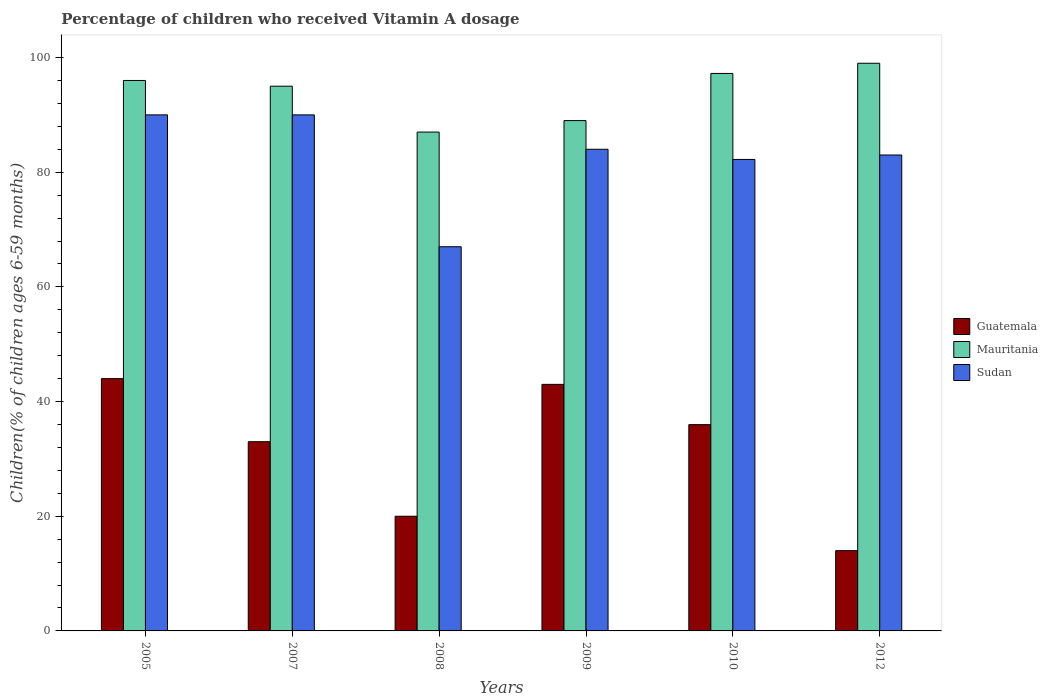How many different coloured bars are there?
Your answer should be compact. 3. Are the number of bars per tick equal to the number of legend labels?
Your answer should be compact. Yes. How many bars are there on the 4th tick from the left?
Your answer should be very brief. 3. What is the label of the 2nd group of bars from the left?
Ensure brevity in your answer.  2007. In how many cases, is the number of bars for a given year not equal to the number of legend labels?
Give a very brief answer. 0. What is the percentage of children who received Vitamin A dosage in Mauritania in 2009?
Your answer should be very brief. 89. Across all years, what is the maximum percentage of children who received Vitamin A dosage in Mauritania?
Keep it short and to the point. 99. In which year was the percentage of children who received Vitamin A dosage in Mauritania maximum?
Your answer should be very brief. 2012. In which year was the percentage of children who received Vitamin A dosage in Sudan minimum?
Ensure brevity in your answer.  2008. What is the total percentage of children who received Vitamin A dosage in Guatemala in the graph?
Your answer should be very brief. 189.98. What is the difference between the percentage of children who received Vitamin A dosage in Mauritania in 2007 and that in 2008?
Your answer should be compact. 8. What is the difference between the percentage of children who received Vitamin A dosage in Sudan in 2007 and the percentage of children who received Vitamin A dosage in Mauritania in 2005?
Your answer should be compact. -6. What is the average percentage of children who received Vitamin A dosage in Mauritania per year?
Your response must be concise. 93.87. In how many years, is the percentage of children who received Vitamin A dosage in Sudan greater than 56 %?
Give a very brief answer. 6. What is the ratio of the percentage of children who received Vitamin A dosage in Sudan in 2010 to that in 2012?
Your response must be concise. 0.99. Is the percentage of children who received Vitamin A dosage in Mauritania in 2007 less than that in 2009?
Your answer should be very brief. No. Is the difference between the percentage of children who received Vitamin A dosage in Sudan in 2005 and 2008 greater than the difference between the percentage of children who received Vitamin A dosage in Guatemala in 2005 and 2008?
Make the answer very short. No. In how many years, is the percentage of children who received Vitamin A dosage in Mauritania greater than the average percentage of children who received Vitamin A dosage in Mauritania taken over all years?
Ensure brevity in your answer.  4. Is the sum of the percentage of children who received Vitamin A dosage in Mauritania in 2008 and 2012 greater than the maximum percentage of children who received Vitamin A dosage in Guatemala across all years?
Make the answer very short. Yes. What does the 3rd bar from the left in 2012 represents?
Offer a very short reply. Sudan. What does the 3rd bar from the right in 2009 represents?
Make the answer very short. Guatemala. Is it the case that in every year, the sum of the percentage of children who received Vitamin A dosage in Mauritania and percentage of children who received Vitamin A dosage in Sudan is greater than the percentage of children who received Vitamin A dosage in Guatemala?
Offer a terse response. Yes. How many years are there in the graph?
Keep it short and to the point. 6. What is the difference between two consecutive major ticks on the Y-axis?
Provide a short and direct response. 20. Where does the legend appear in the graph?
Make the answer very short. Center right. How many legend labels are there?
Give a very brief answer. 3. What is the title of the graph?
Your response must be concise. Percentage of children who received Vitamin A dosage. What is the label or title of the Y-axis?
Give a very brief answer. Children(% of children ages 6-59 months). What is the Children(% of children ages 6-59 months) of Mauritania in 2005?
Offer a very short reply. 96. What is the Children(% of children ages 6-59 months) of Mauritania in 2007?
Provide a short and direct response. 95. What is the Children(% of children ages 6-59 months) of Sudan in 2007?
Offer a terse response. 90. What is the Children(% of children ages 6-59 months) in Mauritania in 2009?
Your response must be concise. 89. What is the Children(% of children ages 6-59 months) of Guatemala in 2010?
Make the answer very short. 35.98. What is the Children(% of children ages 6-59 months) of Mauritania in 2010?
Give a very brief answer. 97.22. What is the Children(% of children ages 6-59 months) of Sudan in 2010?
Your answer should be compact. 82.23. What is the Children(% of children ages 6-59 months) of Guatemala in 2012?
Your answer should be very brief. 14. What is the Children(% of children ages 6-59 months) in Sudan in 2012?
Provide a succinct answer. 83. Across all years, what is the maximum Children(% of children ages 6-59 months) in Guatemala?
Provide a short and direct response. 44. Across all years, what is the minimum Children(% of children ages 6-59 months) in Guatemala?
Your response must be concise. 14. What is the total Children(% of children ages 6-59 months) in Guatemala in the graph?
Provide a succinct answer. 189.98. What is the total Children(% of children ages 6-59 months) in Mauritania in the graph?
Your answer should be compact. 563.22. What is the total Children(% of children ages 6-59 months) of Sudan in the graph?
Give a very brief answer. 496.23. What is the difference between the Children(% of children ages 6-59 months) in Guatemala in 2005 and that in 2007?
Offer a very short reply. 11. What is the difference between the Children(% of children ages 6-59 months) in Sudan in 2005 and that in 2007?
Keep it short and to the point. 0. What is the difference between the Children(% of children ages 6-59 months) of Sudan in 2005 and that in 2008?
Your answer should be compact. 23. What is the difference between the Children(% of children ages 6-59 months) of Guatemala in 2005 and that in 2009?
Make the answer very short. 1. What is the difference between the Children(% of children ages 6-59 months) in Mauritania in 2005 and that in 2009?
Make the answer very short. 7. What is the difference between the Children(% of children ages 6-59 months) in Guatemala in 2005 and that in 2010?
Provide a short and direct response. 8.02. What is the difference between the Children(% of children ages 6-59 months) in Mauritania in 2005 and that in 2010?
Make the answer very short. -1.22. What is the difference between the Children(% of children ages 6-59 months) of Sudan in 2005 and that in 2010?
Make the answer very short. 7.77. What is the difference between the Children(% of children ages 6-59 months) in Guatemala in 2005 and that in 2012?
Your response must be concise. 30. What is the difference between the Children(% of children ages 6-59 months) in Mauritania in 2007 and that in 2008?
Offer a terse response. 8. What is the difference between the Children(% of children ages 6-59 months) of Guatemala in 2007 and that in 2009?
Ensure brevity in your answer.  -10. What is the difference between the Children(% of children ages 6-59 months) of Guatemala in 2007 and that in 2010?
Your answer should be very brief. -2.98. What is the difference between the Children(% of children ages 6-59 months) in Mauritania in 2007 and that in 2010?
Offer a very short reply. -2.22. What is the difference between the Children(% of children ages 6-59 months) in Sudan in 2007 and that in 2010?
Provide a short and direct response. 7.77. What is the difference between the Children(% of children ages 6-59 months) of Mauritania in 2007 and that in 2012?
Ensure brevity in your answer.  -4. What is the difference between the Children(% of children ages 6-59 months) of Guatemala in 2008 and that in 2009?
Make the answer very short. -23. What is the difference between the Children(% of children ages 6-59 months) in Mauritania in 2008 and that in 2009?
Keep it short and to the point. -2. What is the difference between the Children(% of children ages 6-59 months) in Sudan in 2008 and that in 2009?
Keep it short and to the point. -17. What is the difference between the Children(% of children ages 6-59 months) of Guatemala in 2008 and that in 2010?
Offer a terse response. -15.98. What is the difference between the Children(% of children ages 6-59 months) in Mauritania in 2008 and that in 2010?
Provide a short and direct response. -10.22. What is the difference between the Children(% of children ages 6-59 months) in Sudan in 2008 and that in 2010?
Ensure brevity in your answer.  -15.23. What is the difference between the Children(% of children ages 6-59 months) of Guatemala in 2008 and that in 2012?
Provide a succinct answer. 6. What is the difference between the Children(% of children ages 6-59 months) in Mauritania in 2008 and that in 2012?
Provide a succinct answer. -12. What is the difference between the Children(% of children ages 6-59 months) of Sudan in 2008 and that in 2012?
Give a very brief answer. -16. What is the difference between the Children(% of children ages 6-59 months) in Guatemala in 2009 and that in 2010?
Give a very brief answer. 7.02. What is the difference between the Children(% of children ages 6-59 months) of Mauritania in 2009 and that in 2010?
Provide a short and direct response. -8.22. What is the difference between the Children(% of children ages 6-59 months) in Sudan in 2009 and that in 2010?
Provide a short and direct response. 1.77. What is the difference between the Children(% of children ages 6-59 months) of Sudan in 2009 and that in 2012?
Give a very brief answer. 1. What is the difference between the Children(% of children ages 6-59 months) of Guatemala in 2010 and that in 2012?
Your answer should be very brief. 21.98. What is the difference between the Children(% of children ages 6-59 months) of Mauritania in 2010 and that in 2012?
Offer a very short reply. -1.78. What is the difference between the Children(% of children ages 6-59 months) of Sudan in 2010 and that in 2012?
Offer a very short reply. -0.77. What is the difference between the Children(% of children ages 6-59 months) in Guatemala in 2005 and the Children(% of children ages 6-59 months) in Mauritania in 2007?
Provide a succinct answer. -51. What is the difference between the Children(% of children ages 6-59 months) of Guatemala in 2005 and the Children(% of children ages 6-59 months) of Sudan in 2007?
Give a very brief answer. -46. What is the difference between the Children(% of children ages 6-59 months) of Mauritania in 2005 and the Children(% of children ages 6-59 months) of Sudan in 2007?
Your response must be concise. 6. What is the difference between the Children(% of children ages 6-59 months) of Guatemala in 2005 and the Children(% of children ages 6-59 months) of Mauritania in 2008?
Make the answer very short. -43. What is the difference between the Children(% of children ages 6-59 months) of Mauritania in 2005 and the Children(% of children ages 6-59 months) of Sudan in 2008?
Provide a short and direct response. 29. What is the difference between the Children(% of children ages 6-59 months) in Guatemala in 2005 and the Children(% of children ages 6-59 months) in Mauritania in 2009?
Keep it short and to the point. -45. What is the difference between the Children(% of children ages 6-59 months) of Guatemala in 2005 and the Children(% of children ages 6-59 months) of Sudan in 2009?
Your answer should be compact. -40. What is the difference between the Children(% of children ages 6-59 months) in Mauritania in 2005 and the Children(% of children ages 6-59 months) in Sudan in 2009?
Make the answer very short. 12. What is the difference between the Children(% of children ages 6-59 months) in Guatemala in 2005 and the Children(% of children ages 6-59 months) in Mauritania in 2010?
Ensure brevity in your answer.  -53.22. What is the difference between the Children(% of children ages 6-59 months) in Guatemala in 2005 and the Children(% of children ages 6-59 months) in Sudan in 2010?
Give a very brief answer. -38.23. What is the difference between the Children(% of children ages 6-59 months) of Mauritania in 2005 and the Children(% of children ages 6-59 months) of Sudan in 2010?
Keep it short and to the point. 13.77. What is the difference between the Children(% of children ages 6-59 months) in Guatemala in 2005 and the Children(% of children ages 6-59 months) in Mauritania in 2012?
Keep it short and to the point. -55. What is the difference between the Children(% of children ages 6-59 months) of Guatemala in 2005 and the Children(% of children ages 6-59 months) of Sudan in 2012?
Provide a succinct answer. -39. What is the difference between the Children(% of children ages 6-59 months) in Mauritania in 2005 and the Children(% of children ages 6-59 months) in Sudan in 2012?
Offer a very short reply. 13. What is the difference between the Children(% of children ages 6-59 months) in Guatemala in 2007 and the Children(% of children ages 6-59 months) in Mauritania in 2008?
Your response must be concise. -54. What is the difference between the Children(% of children ages 6-59 months) of Guatemala in 2007 and the Children(% of children ages 6-59 months) of Sudan in 2008?
Provide a short and direct response. -34. What is the difference between the Children(% of children ages 6-59 months) of Mauritania in 2007 and the Children(% of children ages 6-59 months) of Sudan in 2008?
Provide a succinct answer. 28. What is the difference between the Children(% of children ages 6-59 months) in Guatemala in 2007 and the Children(% of children ages 6-59 months) in Mauritania in 2009?
Your answer should be compact. -56. What is the difference between the Children(% of children ages 6-59 months) of Guatemala in 2007 and the Children(% of children ages 6-59 months) of Sudan in 2009?
Ensure brevity in your answer.  -51. What is the difference between the Children(% of children ages 6-59 months) in Guatemala in 2007 and the Children(% of children ages 6-59 months) in Mauritania in 2010?
Make the answer very short. -64.22. What is the difference between the Children(% of children ages 6-59 months) of Guatemala in 2007 and the Children(% of children ages 6-59 months) of Sudan in 2010?
Provide a succinct answer. -49.23. What is the difference between the Children(% of children ages 6-59 months) of Mauritania in 2007 and the Children(% of children ages 6-59 months) of Sudan in 2010?
Your response must be concise. 12.77. What is the difference between the Children(% of children ages 6-59 months) of Guatemala in 2007 and the Children(% of children ages 6-59 months) of Mauritania in 2012?
Your response must be concise. -66. What is the difference between the Children(% of children ages 6-59 months) of Mauritania in 2007 and the Children(% of children ages 6-59 months) of Sudan in 2012?
Your answer should be very brief. 12. What is the difference between the Children(% of children ages 6-59 months) in Guatemala in 2008 and the Children(% of children ages 6-59 months) in Mauritania in 2009?
Provide a succinct answer. -69. What is the difference between the Children(% of children ages 6-59 months) of Guatemala in 2008 and the Children(% of children ages 6-59 months) of Sudan in 2009?
Offer a terse response. -64. What is the difference between the Children(% of children ages 6-59 months) in Guatemala in 2008 and the Children(% of children ages 6-59 months) in Mauritania in 2010?
Offer a terse response. -77.22. What is the difference between the Children(% of children ages 6-59 months) of Guatemala in 2008 and the Children(% of children ages 6-59 months) of Sudan in 2010?
Provide a succinct answer. -62.23. What is the difference between the Children(% of children ages 6-59 months) of Mauritania in 2008 and the Children(% of children ages 6-59 months) of Sudan in 2010?
Provide a succinct answer. 4.77. What is the difference between the Children(% of children ages 6-59 months) of Guatemala in 2008 and the Children(% of children ages 6-59 months) of Mauritania in 2012?
Offer a terse response. -79. What is the difference between the Children(% of children ages 6-59 months) of Guatemala in 2008 and the Children(% of children ages 6-59 months) of Sudan in 2012?
Offer a terse response. -63. What is the difference between the Children(% of children ages 6-59 months) in Guatemala in 2009 and the Children(% of children ages 6-59 months) in Mauritania in 2010?
Your response must be concise. -54.22. What is the difference between the Children(% of children ages 6-59 months) of Guatemala in 2009 and the Children(% of children ages 6-59 months) of Sudan in 2010?
Provide a succinct answer. -39.23. What is the difference between the Children(% of children ages 6-59 months) of Mauritania in 2009 and the Children(% of children ages 6-59 months) of Sudan in 2010?
Make the answer very short. 6.77. What is the difference between the Children(% of children ages 6-59 months) of Guatemala in 2009 and the Children(% of children ages 6-59 months) of Mauritania in 2012?
Keep it short and to the point. -56. What is the difference between the Children(% of children ages 6-59 months) of Guatemala in 2009 and the Children(% of children ages 6-59 months) of Sudan in 2012?
Offer a very short reply. -40. What is the difference between the Children(% of children ages 6-59 months) of Mauritania in 2009 and the Children(% of children ages 6-59 months) of Sudan in 2012?
Your answer should be very brief. 6. What is the difference between the Children(% of children ages 6-59 months) of Guatemala in 2010 and the Children(% of children ages 6-59 months) of Mauritania in 2012?
Ensure brevity in your answer.  -63.02. What is the difference between the Children(% of children ages 6-59 months) in Guatemala in 2010 and the Children(% of children ages 6-59 months) in Sudan in 2012?
Your response must be concise. -47.02. What is the difference between the Children(% of children ages 6-59 months) in Mauritania in 2010 and the Children(% of children ages 6-59 months) in Sudan in 2012?
Offer a terse response. 14.22. What is the average Children(% of children ages 6-59 months) in Guatemala per year?
Provide a succinct answer. 31.66. What is the average Children(% of children ages 6-59 months) in Mauritania per year?
Keep it short and to the point. 93.87. What is the average Children(% of children ages 6-59 months) in Sudan per year?
Make the answer very short. 82.7. In the year 2005, what is the difference between the Children(% of children ages 6-59 months) in Guatemala and Children(% of children ages 6-59 months) in Mauritania?
Provide a succinct answer. -52. In the year 2005, what is the difference between the Children(% of children ages 6-59 months) of Guatemala and Children(% of children ages 6-59 months) of Sudan?
Your answer should be very brief. -46. In the year 2005, what is the difference between the Children(% of children ages 6-59 months) in Mauritania and Children(% of children ages 6-59 months) in Sudan?
Make the answer very short. 6. In the year 2007, what is the difference between the Children(% of children ages 6-59 months) in Guatemala and Children(% of children ages 6-59 months) in Mauritania?
Keep it short and to the point. -62. In the year 2007, what is the difference between the Children(% of children ages 6-59 months) of Guatemala and Children(% of children ages 6-59 months) of Sudan?
Make the answer very short. -57. In the year 2008, what is the difference between the Children(% of children ages 6-59 months) in Guatemala and Children(% of children ages 6-59 months) in Mauritania?
Provide a succinct answer. -67. In the year 2008, what is the difference between the Children(% of children ages 6-59 months) of Guatemala and Children(% of children ages 6-59 months) of Sudan?
Make the answer very short. -47. In the year 2008, what is the difference between the Children(% of children ages 6-59 months) of Mauritania and Children(% of children ages 6-59 months) of Sudan?
Give a very brief answer. 20. In the year 2009, what is the difference between the Children(% of children ages 6-59 months) of Guatemala and Children(% of children ages 6-59 months) of Mauritania?
Make the answer very short. -46. In the year 2009, what is the difference between the Children(% of children ages 6-59 months) of Guatemala and Children(% of children ages 6-59 months) of Sudan?
Give a very brief answer. -41. In the year 2010, what is the difference between the Children(% of children ages 6-59 months) of Guatemala and Children(% of children ages 6-59 months) of Mauritania?
Ensure brevity in your answer.  -61.25. In the year 2010, what is the difference between the Children(% of children ages 6-59 months) of Guatemala and Children(% of children ages 6-59 months) of Sudan?
Your response must be concise. -46.25. In the year 2010, what is the difference between the Children(% of children ages 6-59 months) of Mauritania and Children(% of children ages 6-59 months) of Sudan?
Your response must be concise. 15. In the year 2012, what is the difference between the Children(% of children ages 6-59 months) of Guatemala and Children(% of children ages 6-59 months) of Mauritania?
Offer a very short reply. -85. In the year 2012, what is the difference between the Children(% of children ages 6-59 months) of Guatemala and Children(% of children ages 6-59 months) of Sudan?
Ensure brevity in your answer.  -69. In the year 2012, what is the difference between the Children(% of children ages 6-59 months) of Mauritania and Children(% of children ages 6-59 months) of Sudan?
Your answer should be very brief. 16. What is the ratio of the Children(% of children ages 6-59 months) in Mauritania in 2005 to that in 2007?
Your answer should be very brief. 1.01. What is the ratio of the Children(% of children ages 6-59 months) in Sudan in 2005 to that in 2007?
Provide a succinct answer. 1. What is the ratio of the Children(% of children ages 6-59 months) of Mauritania in 2005 to that in 2008?
Ensure brevity in your answer.  1.1. What is the ratio of the Children(% of children ages 6-59 months) of Sudan in 2005 to that in 2008?
Give a very brief answer. 1.34. What is the ratio of the Children(% of children ages 6-59 months) of Guatemala in 2005 to that in 2009?
Offer a very short reply. 1.02. What is the ratio of the Children(% of children ages 6-59 months) in Mauritania in 2005 to that in 2009?
Make the answer very short. 1.08. What is the ratio of the Children(% of children ages 6-59 months) of Sudan in 2005 to that in 2009?
Your answer should be very brief. 1.07. What is the ratio of the Children(% of children ages 6-59 months) of Guatemala in 2005 to that in 2010?
Ensure brevity in your answer.  1.22. What is the ratio of the Children(% of children ages 6-59 months) in Mauritania in 2005 to that in 2010?
Make the answer very short. 0.99. What is the ratio of the Children(% of children ages 6-59 months) in Sudan in 2005 to that in 2010?
Give a very brief answer. 1.09. What is the ratio of the Children(% of children ages 6-59 months) of Guatemala in 2005 to that in 2012?
Offer a terse response. 3.14. What is the ratio of the Children(% of children ages 6-59 months) of Mauritania in 2005 to that in 2012?
Make the answer very short. 0.97. What is the ratio of the Children(% of children ages 6-59 months) in Sudan in 2005 to that in 2012?
Provide a succinct answer. 1.08. What is the ratio of the Children(% of children ages 6-59 months) of Guatemala in 2007 to that in 2008?
Your answer should be very brief. 1.65. What is the ratio of the Children(% of children ages 6-59 months) in Mauritania in 2007 to that in 2008?
Your answer should be compact. 1.09. What is the ratio of the Children(% of children ages 6-59 months) in Sudan in 2007 to that in 2008?
Keep it short and to the point. 1.34. What is the ratio of the Children(% of children ages 6-59 months) of Guatemala in 2007 to that in 2009?
Offer a terse response. 0.77. What is the ratio of the Children(% of children ages 6-59 months) of Mauritania in 2007 to that in 2009?
Provide a short and direct response. 1.07. What is the ratio of the Children(% of children ages 6-59 months) in Sudan in 2007 to that in 2009?
Offer a very short reply. 1.07. What is the ratio of the Children(% of children ages 6-59 months) of Guatemala in 2007 to that in 2010?
Provide a succinct answer. 0.92. What is the ratio of the Children(% of children ages 6-59 months) of Mauritania in 2007 to that in 2010?
Your answer should be compact. 0.98. What is the ratio of the Children(% of children ages 6-59 months) in Sudan in 2007 to that in 2010?
Make the answer very short. 1.09. What is the ratio of the Children(% of children ages 6-59 months) of Guatemala in 2007 to that in 2012?
Provide a short and direct response. 2.36. What is the ratio of the Children(% of children ages 6-59 months) in Mauritania in 2007 to that in 2012?
Ensure brevity in your answer.  0.96. What is the ratio of the Children(% of children ages 6-59 months) of Sudan in 2007 to that in 2012?
Your response must be concise. 1.08. What is the ratio of the Children(% of children ages 6-59 months) in Guatemala in 2008 to that in 2009?
Offer a terse response. 0.47. What is the ratio of the Children(% of children ages 6-59 months) in Mauritania in 2008 to that in 2009?
Provide a short and direct response. 0.98. What is the ratio of the Children(% of children ages 6-59 months) of Sudan in 2008 to that in 2009?
Provide a succinct answer. 0.8. What is the ratio of the Children(% of children ages 6-59 months) in Guatemala in 2008 to that in 2010?
Keep it short and to the point. 0.56. What is the ratio of the Children(% of children ages 6-59 months) of Mauritania in 2008 to that in 2010?
Make the answer very short. 0.89. What is the ratio of the Children(% of children ages 6-59 months) of Sudan in 2008 to that in 2010?
Provide a short and direct response. 0.81. What is the ratio of the Children(% of children ages 6-59 months) of Guatemala in 2008 to that in 2012?
Keep it short and to the point. 1.43. What is the ratio of the Children(% of children ages 6-59 months) of Mauritania in 2008 to that in 2012?
Your response must be concise. 0.88. What is the ratio of the Children(% of children ages 6-59 months) in Sudan in 2008 to that in 2012?
Make the answer very short. 0.81. What is the ratio of the Children(% of children ages 6-59 months) in Guatemala in 2009 to that in 2010?
Offer a very short reply. 1.2. What is the ratio of the Children(% of children ages 6-59 months) of Mauritania in 2009 to that in 2010?
Your answer should be very brief. 0.92. What is the ratio of the Children(% of children ages 6-59 months) of Sudan in 2009 to that in 2010?
Provide a succinct answer. 1.02. What is the ratio of the Children(% of children ages 6-59 months) of Guatemala in 2009 to that in 2012?
Offer a very short reply. 3.07. What is the ratio of the Children(% of children ages 6-59 months) of Mauritania in 2009 to that in 2012?
Your response must be concise. 0.9. What is the ratio of the Children(% of children ages 6-59 months) in Sudan in 2009 to that in 2012?
Keep it short and to the point. 1.01. What is the ratio of the Children(% of children ages 6-59 months) in Guatemala in 2010 to that in 2012?
Ensure brevity in your answer.  2.57. What is the ratio of the Children(% of children ages 6-59 months) in Mauritania in 2010 to that in 2012?
Offer a terse response. 0.98. What is the difference between the highest and the second highest Children(% of children ages 6-59 months) of Guatemala?
Give a very brief answer. 1. What is the difference between the highest and the second highest Children(% of children ages 6-59 months) of Mauritania?
Ensure brevity in your answer.  1.78. 